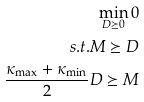<formula> <loc_0><loc_0><loc_500><loc_500>\min _ { D \succeq 0 } 0 \\ s . t . M \succeq D \\ \frac { \kappa _ { \max } + \kappa _ { \min } } { 2 } D \succeq M</formula> 